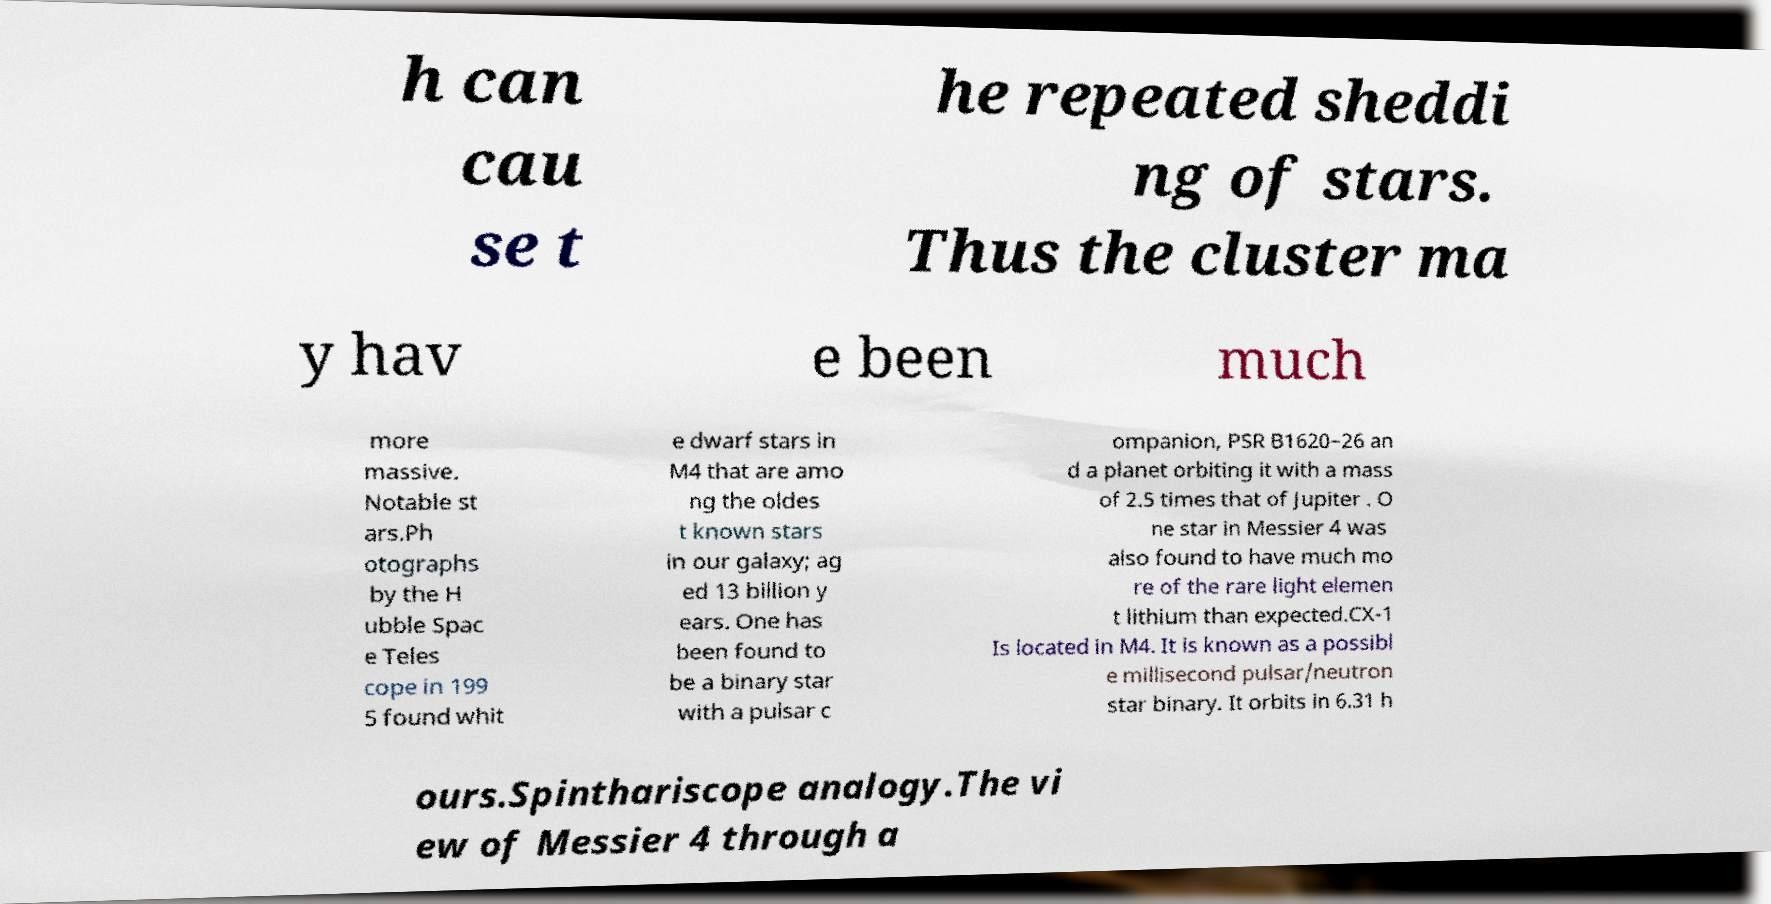There's text embedded in this image that I need extracted. Can you transcribe it verbatim? h can cau se t he repeated sheddi ng of stars. Thus the cluster ma y hav e been much more massive. Notable st ars.Ph otographs by the H ubble Spac e Teles cope in 199 5 found whit e dwarf stars in M4 that are amo ng the oldes t known stars in our galaxy; ag ed 13 billion y ears. One has been found to be a binary star with a pulsar c ompanion, PSR B1620−26 an d a planet orbiting it with a mass of 2.5 times that of Jupiter . O ne star in Messier 4 was also found to have much mo re of the rare light elemen t lithium than expected.CX-1 Is located in M4. It is known as a possibl e millisecond pulsar/neutron star binary. It orbits in 6.31 h ours.Spinthariscope analogy.The vi ew of Messier 4 through a 